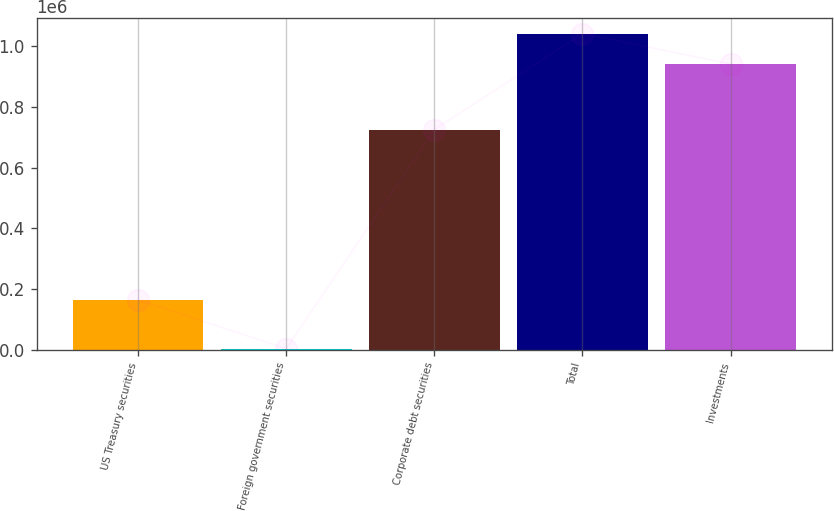Convert chart to OTSL. <chart><loc_0><loc_0><loc_500><loc_500><bar_chart><fcel>US Treasury securities<fcel>Foreign government securities<fcel>Corporate debt securities<fcel>Total<fcel>Investments<nl><fcel>164619<fcel>3486<fcel>725778<fcel>1.04189e+06<fcel>941989<nl></chart> 